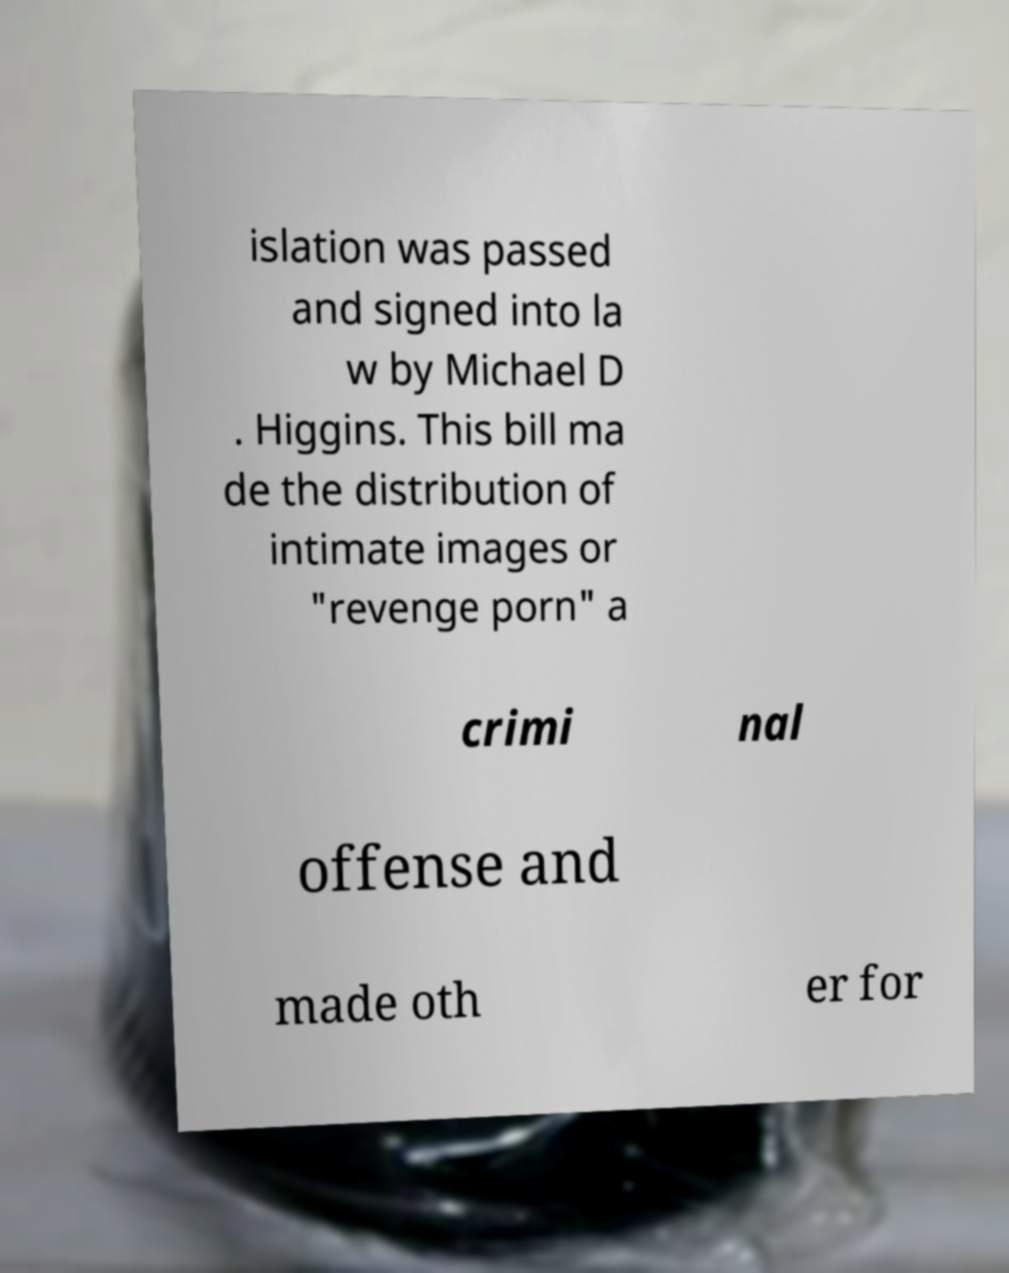For documentation purposes, I need the text within this image transcribed. Could you provide that? islation was passed and signed into la w by Michael D . Higgins. This bill ma de the distribution of intimate images or "revenge porn" a crimi nal offense and made oth er for 